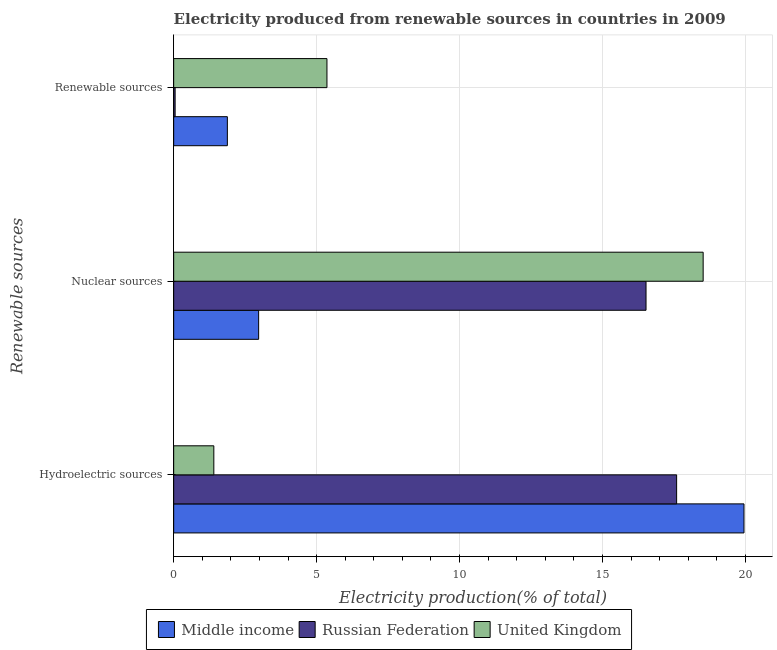How many different coloured bars are there?
Ensure brevity in your answer.  3. How many groups of bars are there?
Your answer should be compact. 3. What is the label of the 2nd group of bars from the top?
Make the answer very short. Nuclear sources. What is the percentage of electricity produced by nuclear sources in United Kingdom?
Your answer should be compact. 18.52. Across all countries, what is the maximum percentage of electricity produced by nuclear sources?
Offer a very short reply. 18.52. Across all countries, what is the minimum percentage of electricity produced by hydroelectric sources?
Provide a short and direct response. 1.4. In which country was the percentage of electricity produced by hydroelectric sources minimum?
Provide a short and direct response. United Kingdom. What is the total percentage of electricity produced by hydroelectric sources in the graph?
Your answer should be very brief. 38.95. What is the difference between the percentage of electricity produced by renewable sources in Middle income and that in United Kingdom?
Your answer should be very brief. -3.48. What is the difference between the percentage of electricity produced by renewable sources in United Kingdom and the percentage of electricity produced by hydroelectric sources in Middle income?
Give a very brief answer. -14.59. What is the average percentage of electricity produced by renewable sources per country?
Give a very brief answer. 2.43. What is the difference between the percentage of electricity produced by renewable sources and percentage of electricity produced by nuclear sources in United Kingdom?
Provide a succinct answer. -13.16. In how many countries, is the percentage of electricity produced by hydroelectric sources greater than 11 %?
Your response must be concise. 2. What is the ratio of the percentage of electricity produced by renewable sources in Russian Federation to that in Middle income?
Offer a very short reply. 0.03. Is the difference between the percentage of electricity produced by renewable sources in United Kingdom and Middle income greater than the difference between the percentage of electricity produced by hydroelectric sources in United Kingdom and Middle income?
Provide a short and direct response. Yes. What is the difference between the highest and the second highest percentage of electricity produced by renewable sources?
Your answer should be very brief. 3.48. What is the difference between the highest and the lowest percentage of electricity produced by hydroelectric sources?
Keep it short and to the point. 18.54. Is it the case that in every country, the sum of the percentage of electricity produced by hydroelectric sources and percentage of electricity produced by nuclear sources is greater than the percentage of electricity produced by renewable sources?
Your answer should be very brief. Yes. How many bars are there?
Provide a short and direct response. 9. Are all the bars in the graph horizontal?
Your answer should be compact. Yes. How many countries are there in the graph?
Your answer should be very brief. 3. What is the difference between two consecutive major ticks on the X-axis?
Ensure brevity in your answer.  5. Are the values on the major ticks of X-axis written in scientific E-notation?
Your answer should be compact. No. Does the graph contain any zero values?
Give a very brief answer. No. What is the title of the graph?
Your answer should be compact. Electricity produced from renewable sources in countries in 2009. Does "Norway" appear as one of the legend labels in the graph?
Your answer should be very brief. No. What is the label or title of the X-axis?
Provide a short and direct response. Electricity production(% of total). What is the label or title of the Y-axis?
Your answer should be compact. Renewable sources. What is the Electricity production(% of total) in Middle income in Hydroelectric sources?
Offer a terse response. 19.95. What is the Electricity production(% of total) in Russian Federation in Hydroelectric sources?
Make the answer very short. 17.59. What is the Electricity production(% of total) of United Kingdom in Hydroelectric sources?
Make the answer very short. 1.4. What is the Electricity production(% of total) in Middle income in Nuclear sources?
Provide a short and direct response. 2.97. What is the Electricity production(% of total) in Russian Federation in Nuclear sources?
Your answer should be very brief. 16.52. What is the Electricity production(% of total) in United Kingdom in Nuclear sources?
Give a very brief answer. 18.52. What is the Electricity production(% of total) in Middle income in Renewable sources?
Provide a short and direct response. 1.88. What is the Electricity production(% of total) of Russian Federation in Renewable sources?
Make the answer very short. 0.05. What is the Electricity production(% of total) in United Kingdom in Renewable sources?
Your response must be concise. 5.36. Across all Renewable sources, what is the maximum Electricity production(% of total) in Middle income?
Offer a terse response. 19.95. Across all Renewable sources, what is the maximum Electricity production(% of total) of Russian Federation?
Make the answer very short. 17.59. Across all Renewable sources, what is the maximum Electricity production(% of total) of United Kingdom?
Provide a short and direct response. 18.52. Across all Renewable sources, what is the minimum Electricity production(% of total) in Middle income?
Make the answer very short. 1.88. Across all Renewable sources, what is the minimum Electricity production(% of total) of Russian Federation?
Your answer should be very brief. 0.05. Across all Renewable sources, what is the minimum Electricity production(% of total) of United Kingdom?
Your answer should be very brief. 1.4. What is the total Electricity production(% of total) of Middle income in the graph?
Offer a very short reply. 24.8. What is the total Electricity production(% of total) of Russian Federation in the graph?
Your answer should be very brief. 34.17. What is the total Electricity production(% of total) of United Kingdom in the graph?
Keep it short and to the point. 25.29. What is the difference between the Electricity production(% of total) of Middle income in Hydroelectric sources and that in Nuclear sources?
Make the answer very short. 16.98. What is the difference between the Electricity production(% of total) in Russian Federation in Hydroelectric sources and that in Nuclear sources?
Give a very brief answer. 1.07. What is the difference between the Electricity production(% of total) in United Kingdom in Hydroelectric sources and that in Nuclear sources?
Your answer should be compact. -17.12. What is the difference between the Electricity production(% of total) in Middle income in Hydroelectric sources and that in Renewable sources?
Your response must be concise. 18.07. What is the difference between the Electricity production(% of total) of Russian Federation in Hydroelectric sources and that in Renewable sources?
Ensure brevity in your answer.  17.54. What is the difference between the Electricity production(% of total) in United Kingdom in Hydroelectric sources and that in Renewable sources?
Offer a very short reply. -3.96. What is the difference between the Electricity production(% of total) of Middle income in Nuclear sources and that in Renewable sources?
Provide a succinct answer. 1.09. What is the difference between the Electricity production(% of total) of Russian Federation in Nuclear sources and that in Renewable sources?
Your answer should be very brief. 16.47. What is the difference between the Electricity production(% of total) of United Kingdom in Nuclear sources and that in Renewable sources?
Your response must be concise. 13.16. What is the difference between the Electricity production(% of total) of Middle income in Hydroelectric sources and the Electricity production(% of total) of Russian Federation in Nuclear sources?
Make the answer very short. 3.43. What is the difference between the Electricity production(% of total) of Middle income in Hydroelectric sources and the Electricity production(% of total) of United Kingdom in Nuclear sources?
Make the answer very short. 1.43. What is the difference between the Electricity production(% of total) of Russian Federation in Hydroelectric sources and the Electricity production(% of total) of United Kingdom in Nuclear sources?
Your answer should be compact. -0.93. What is the difference between the Electricity production(% of total) in Middle income in Hydroelectric sources and the Electricity production(% of total) in Russian Federation in Renewable sources?
Make the answer very short. 19.9. What is the difference between the Electricity production(% of total) in Middle income in Hydroelectric sources and the Electricity production(% of total) in United Kingdom in Renewable sources?
Provide a succinct answer. 14.59. What is the difference between the Electricity production(% of total) of Russian Federation in Hydroelectric sources and the Electricity production(% of total) of United Kingdom in Renewable sources?
Provide a short and direct response. 12.23. What is the difference between the Electricity production(% of total) of Middle income in Nuclear sources and the Electricity production(% of total) of Russian Federation in Renewable sources?
Keep it short and to the point. 2.92. What is the difference between the Electricity production(% of total) in Middle income in Nuclear sources and the Electricity production(% of total) in United Kingdom in Renewable sources?
Your answer should be compact. -2.39. What is the difference between the Electricity production(% of total) in Russian Federation in Nuclear sources and the Electricity production(% of total) in United Kingdom in Renewable sources?
Offer a very short reply. 11.16. What is the average Electricity production(% of total) of Middle income per Renewable sources?
Give a very brief answer. 8.27. What is the average Electricity production(% of total) in Russian Federation per Renewable sources?
Provide a short and direct response. 11.39. What is the average Electricity production(% of total) of United Kingdom per Renewable sources?
Your response must be concise. 8.43. What is the difference between the Electricity production(% of total) of Middle income and Electricity production(% of total) of Russian Federation in Hydroelectric sources?
Offer a terse response. 2.36. What is the difference between the Electricity production(% of total) in Middle income and Electricity production(% of total) in United Kingdom in Hydroelectric sources?
Ensure brevity in your answer.  18.54. What is the difference between the Electricity production(% of total) of Russian Federation and Electricity production(% of total) of United Kingdom in Hydroelectric sources?
Provide a succinct answer. 16.19. What is the difference between the Electricity production(% of total) of Middle income and Electricity production(% of total) of Russian Federation in Nuclear sources?
Keep it short and to the point. -13.55. What is the difference between the Electricity production(% of total) of Middle income and Electricity production(% of total) of United Kingdom in Nuclear sources?
Provide a short and direct response. -15.55. What is the difference between the Electricity production(% of total) of Russian Federation and Electricity production(% of total) of United Kingdom in Nuclear sources?
Provide a short and direct response. -2. What is the difference between the Electricity production(% of total) in Middle income and Electricity production(% of total) in Russian Federation in Renewable sources?
Provide a succinct answer. 1.83. What is the difference between the Electricity production(% of total) of Middle income and Electricity production(% of total) of United Kingdom in Renewable sources?
Offer a very short reply. -3.48. What is the difference between the Electricity production(% of total) in Russian Federation and Electricity production(% of total) in United Kingdom in Renewable sources?
Your answer should be compact. -5.31. What is the ratio of the Electricity production(% of total) in Middle income in Hydroelectric sources to that in Nuclear sources?
Provide a short and direct response. 6.71. What is the ratio of the Electricity production(% of total) in Russian Federation in Hydroelectric sources to that in Nuclear sources?
Your answer should be compact. 1.06. What is the ratio of the Electricity production(% of total) in United Kingdom in Hydroelectric sources to that in Nuclear sources?
Your answer should be very brief. 0.08. What is the ratio of the Electricity production(% of total) of Middle income in Hydroelectric sources to that in Renewable sources?
Make the answer very short. 10.62. What is the ratio of the Electricity production(% of total) in Russian Federation in Hydroelectric sources to that in Renewable sources?
Your response must be concise. 347.67. What is the ratio of the Electricity production(% of total) of United Kingdom in Hydroelectric sources to that in Renewable sources?
Give a very brief answer. 0.26. What is the ratio of the Electricity production(% of total) of Middle income in Nuclear sources to that in Renewable sources?
Offer a terse response. 1.58. What is the ratio of the Electricity production(% of total) of Russian Federation in Nuclear sources to that in Renewable sources?
Offer a terse response. 326.51. What is the ratio of the Electricity production(% of total) in United Kingdom in Nuclear sources to that in Renewable sources?
Provide a succinct answer. 3.45. What is the difference between the highest and the second highest Electricity production(% of total) of Middle income?
Your answer should be compact. 16.98. What is the difference between the highest and the second highest Electricity production(% of total) of Russian Federation?
Provide a succinct answer. 1.07. What is the difference between the highest and the second highest Electricity production(% of total) in United Kingdom?
Keep it short and to the point. 13.16. What is the difference between the highest and the lowest Electricity production(% of total) in Middle income?
Ensure brevity in your answer.  18.07. What is the difference between the highest and the lowest Electricity production(% of total) in Russian Federation?
Make the answer very short. 17.54. What is the difference between the highest and the lowest Electricity production(% of total) in United Kingdom?
Offer a very short reply. 17.12. 